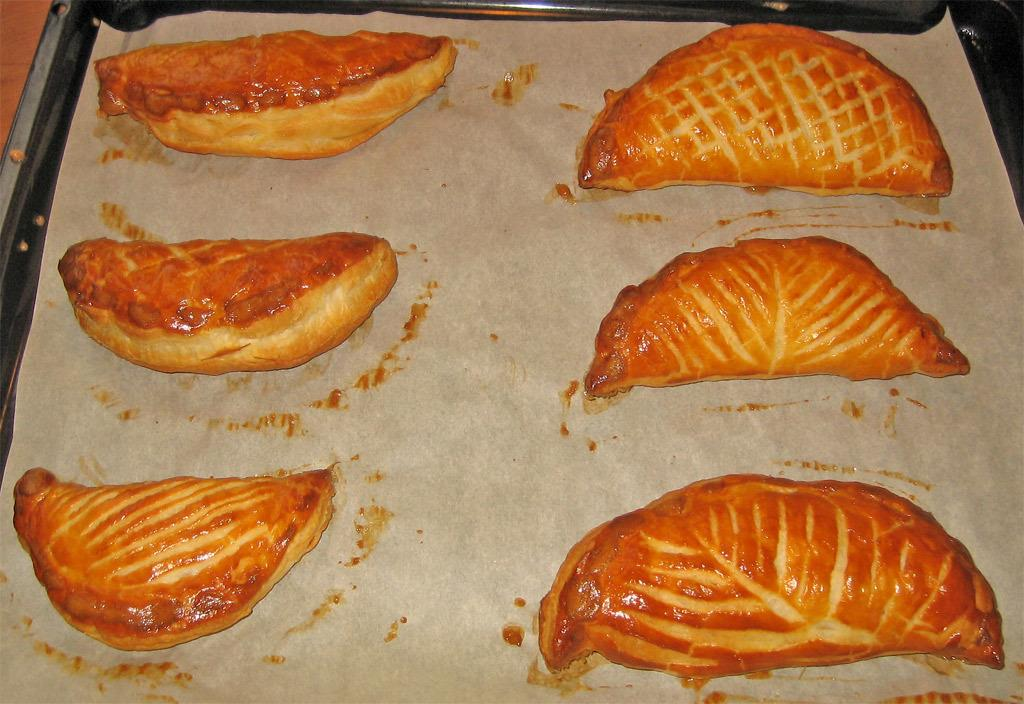What is the main subject of the image? There is a food item in the image. Can you describe the location of the food item? The food item is on a surface. What is the income of the ant in the image? There is no ant present in the image, so it is not possible to determine its income. 